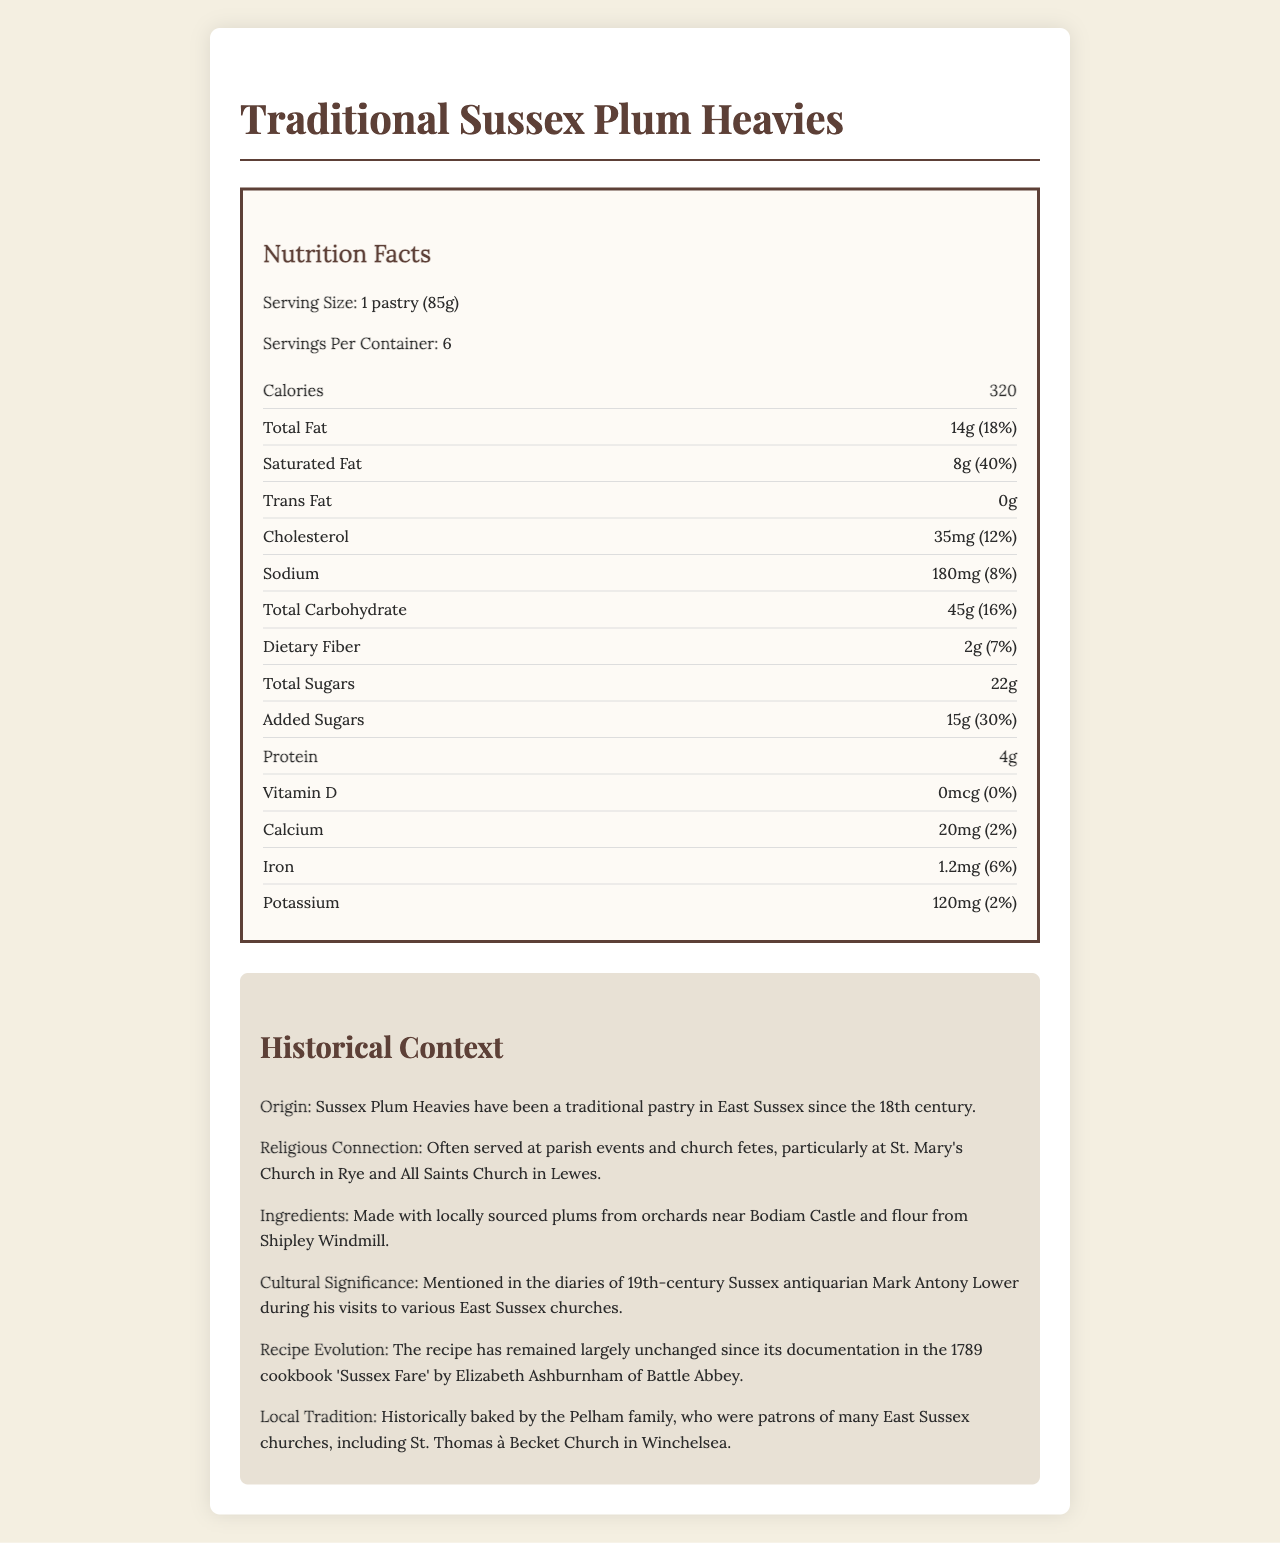what is the serving size for a Traditional Sussex Plum Heavies pastry? The serving size is explicitly mentioned as “1 pastry (85g)” in the document.
Answer: 1 pastry (85g) how many servings are in one container? The document states that there are 6 servings per container.
Answer: 6 how many calories are in one pastry? According to the document, one pastry contains 320 calories.
Answer: 320 how much saturated fat does one pastry contain? The document lists the saturated fat content as 8g for one pastry.
Answer: 8g what percentage of the daily value does the total fat in one pastry provide? The document states that the total fat content is 14g, which is 18% of the daily value.
Answer: 18% which historical figure mentioned Sussex Plum Heavies in their diaries? The historical context section reveals that Mark Antony Lower mentioned Sussex Plum Heavies in his diaries.
Answer: Mark Antony Lower What is the origin of Sussex Plum Heavies? The historical context section states the origin as being an 18th-century traditional pastry from East Sussex.
Answer: Sussex Plum Heavies have been a traditional pastry in East Sussex since the 18th century. Who historically baked the Traditional Sussex Plum Heavies? A. The Pelham family B. The Ashburnham family C. The Bodiam family D. The Rye family The historical context section mentions that the Pelham family historically baked the pastries.
Answer: A What is the main source of plums used in the Traditional Sussex Plum Heavies? 1. Bodiam Castle orchards 2. Shipley Windmill 3. Battle Abbey 4. Lewes market The document specifies that the plums are sourced from orchards near Bodiam Castle.
Answer: 1 True or False: The recipe for Sussex Plum Heavies has undergone significant changes since it was first documented. The recipe evolution section states that the recipe has remained largely unchanged since its documentation in 1789.
Answer: False What is the total carbohydrate content in one pastry? The document lists the total carbohydrate content as 45g for one pastry.
Answer: 45g What is the main idea of this document? The document includes detailed nutritional facts as well as a historical background on the Traditional Sussex Plum Heavies.
Answer: The document provides nutritional information and historical context for Traditional Sussex Plum Heavies, including their origin, cultural significance, and the ingredients used. How much dietary fiber is in one pastry? The dietary fiber content is listed as 2g per pastry in the nutrition facts section.
Answer: 2g What were the main ingredients sourced locally for the Traditional Sussex Plum Heavies? The historical context section lists these as the main locally sourced ingredients.
Answer: Plums from orchards near Bodiam Castle and flour from Shipley Windmill. Which churches were associated with the serving of Sussex Plum Heavies at parish events and church fetes? The religious connection section states these two churches.
Answer: St. Mary’s Church in Rye and All Saints Church in Lewes. How much cholesterol does one pastry contain? The nutrition facts state that one pastry contains 35mg of cholesterol.
Answer: 35mg What is the amount of added sugars in one pastry? The nutrition facts list added sugars as 15g per pastry.
Answer: 15g What cookbook documented the recipe for Sussex Plum Heavies in 1789? The historical context section mentions this cookbook.
Answer: ‘Sussex Fare’ by Elizabeth Ashburnham of Battle Abbey. What is the vitamin D content of one pastry? The nutrition facts indicate that the vitamin D content is 0 mcg.
Answer: 0 mcg What is the main cultural significance of Traditional Sussex Plum Heavies? The cultural significance is highlighted by the mention of Mark Antony Lower’s diaries.
Answer: They are mentioned in the diaries of 19th-century Sussex antiquarian Mark Antony Lower during his visits to East Sussex churches. Why might someone choose to avoid eating Traditional Sussex Plum Heavies regularly? The nutritional information shows high saturated fat (40% DV) and added sugars (30% DV).
Answer: The pastry contains high levels of saturated fat and added sugars, which may not be suitable for a balanced diet. What is the sodium content in one pastry? The nutrition facts list the sodium content as 180mg.
Answer: 180mg What is the historical connection between the Pelham family and Traditional Sussex Plum Heavies? The local tradition section mentions the Pelham family’s historical role in baking the pastries.
Answer: The Pelham family, who were patrons of many East Sussex churches, historically baked the pastries. How many grams of protein are in one pastry? The nutrition facts state the protein content as 4g per pastry.
Answer: 4g Which church in Rye is associated with the serving of Sussex Plum Heavies? The religious connection section specifically mentions St. Mary's Church in Rye.
Answer: St. Mary's Church Does the article mention how to make Sussex Plum Heavies? The article provides historical context and nutritional information but does not give detailed instructions on how to make the pastry.
Answer: Not enough information 